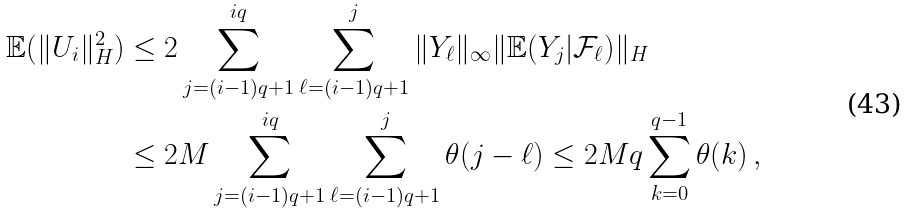Convert formula to latex. <formula><loc_0><loc_0><loc_500><loc_500>{ \mathbb { E } } ( \| U _ { i } \| _ { H } ^ { 2 } ) & \leq 2 \sum _ { j = ( i - 1 ) q + 1 } ^ { i q } \sum _ { \ell = ( i - 1 ) q + 1 } ^ { j } \| Y _ { \ell } \| _ { \infty } \| { \mathbb { E } } ( Y _ { j } | { \mathcal { F } } _ { \ell } ) \| _ { H } \\ & \leq 2 M \sum _ { j = ( i - 1 ) q + 1 } ^ { i q } \sum _ { \ell = ( i - 1 ) q + 1 } ^ { j } \theta ( j - \ell ) \leq 2 M q \sum _ { k = 0 } ^ { q - 1 } \theta ( k ) \, ,</formula> 